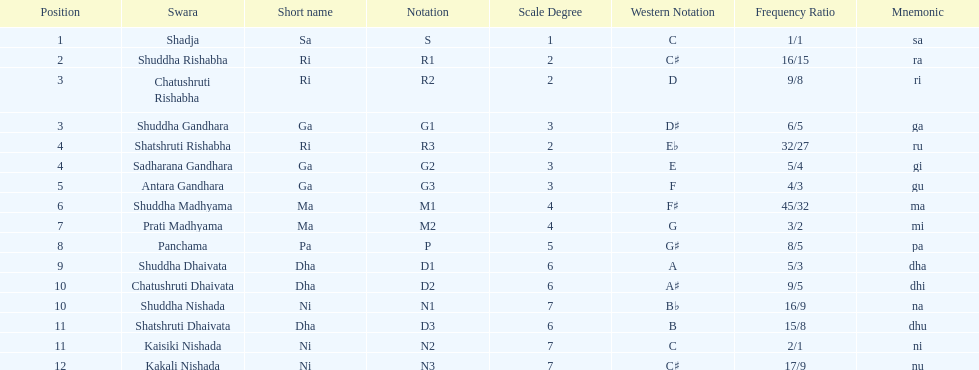Find the 9th position swara. what is its short name? Dha. 